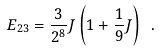<formula> <loc_0><loc_0><loc_500><loc_500>E _ { 2 3 } = \frac { 3 } { 2 ^ { 8 } } J \left ( 1 + \frac { 1 } { 9 } J \right ) \ .</formula> 